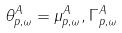<formula> <loc_0><loc_0><loc_500><loc_500>\theta _ { p , \omega } ^ { A } = \mu _ { p , \omega } ^ { A } , \Gamma _ { p , \omega } ^ { A }</formula> 